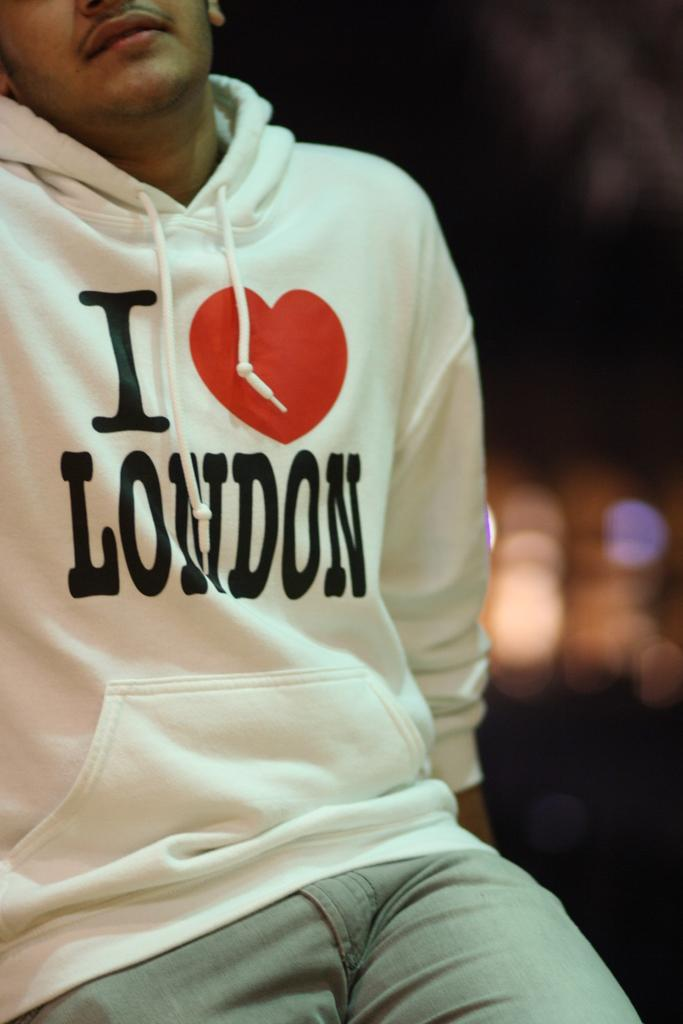Who or what is the main subject in the image? There is a person in the image. Can you describe the background of the image? The background of the image is blurry. What level of experience does the lock have in the image? There is no lock present in the image. How quiet is the person in the image? The image does not provide information about the person's level of noise or quietness. 